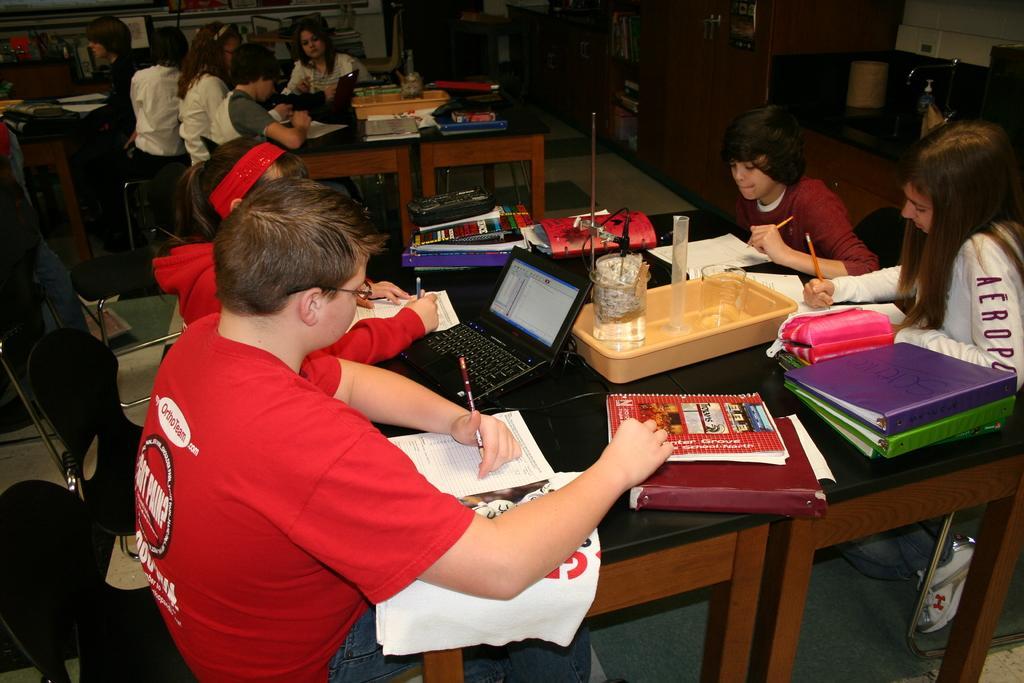How would you summarize this image in a sentence or two? In the image we can see group of persons were sitting around the table. On table there is a tab,basket,bag,files,books,pens,covers,keyboard,microphone,vase etc. In the background there is a cupboard,sink,tap,wall and door. 